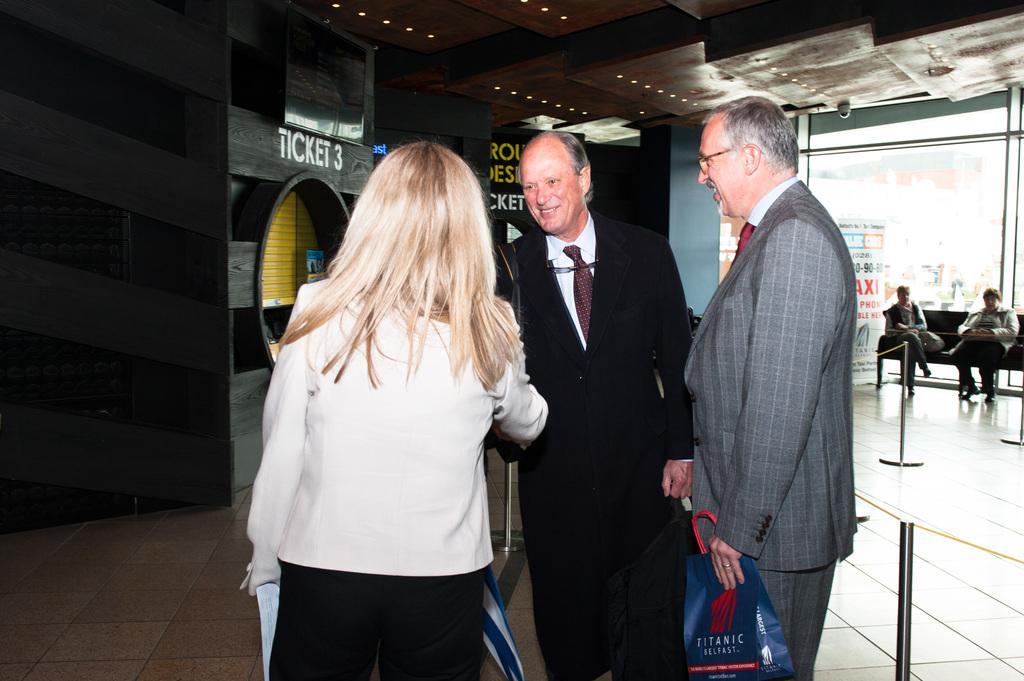Could you give a brief overview of what you see in this image? There are three people standing on the floor and this man holding a bag. In the background there are two people,sitting on sofa,beside this sofa we can see banner,glass and wall. At the top we can see lights and camera. 